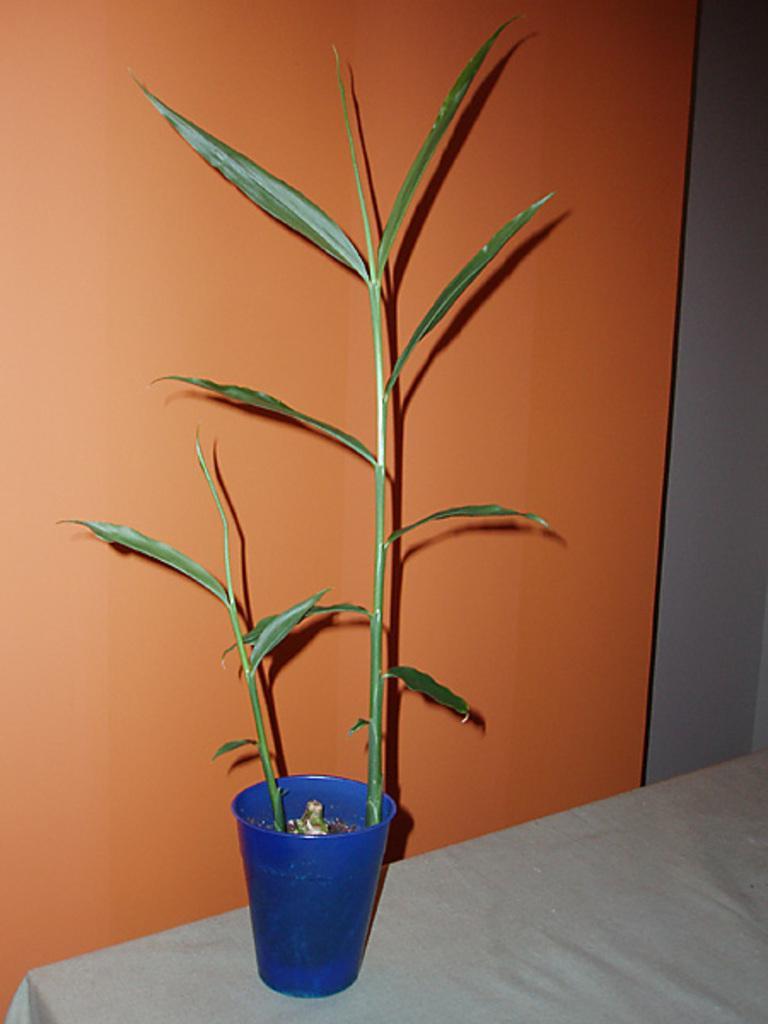Could you give a brief overview of what you see in this image? In this picture there is a small bamboo plant in the blue pot, placed on the table top. Behind there is a orange color wall. 